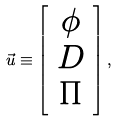Convert formula to latex. <formula><loc_0><loc_0><loc_500><loc_500>\vec { u } \equiv \left [ \begin{array} { c } \phi \\ D \\ \Pi \end{array} \right ] ,</formula> 